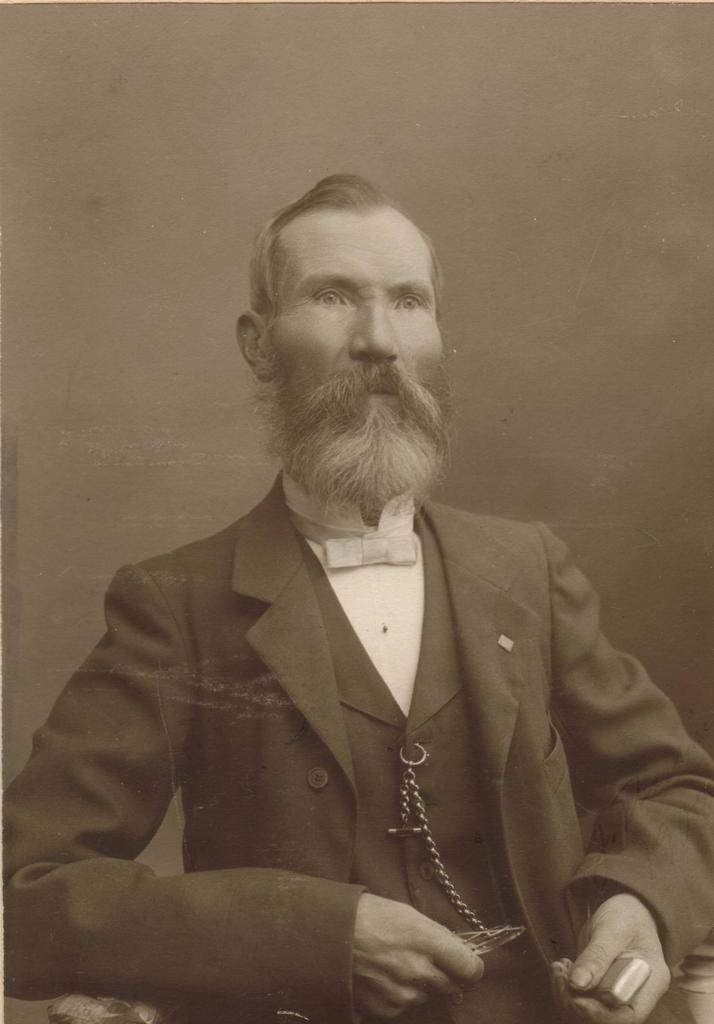What is the color scheme of the image? The image is black and white. Who is present in the image? There is a man in the image. What is the man doing in the image? The man is holding something in his hands. How many balls can be seen growing in the image? There are no balls or growth visible in the image; it is a black and white image of a man holding something in his hands. 